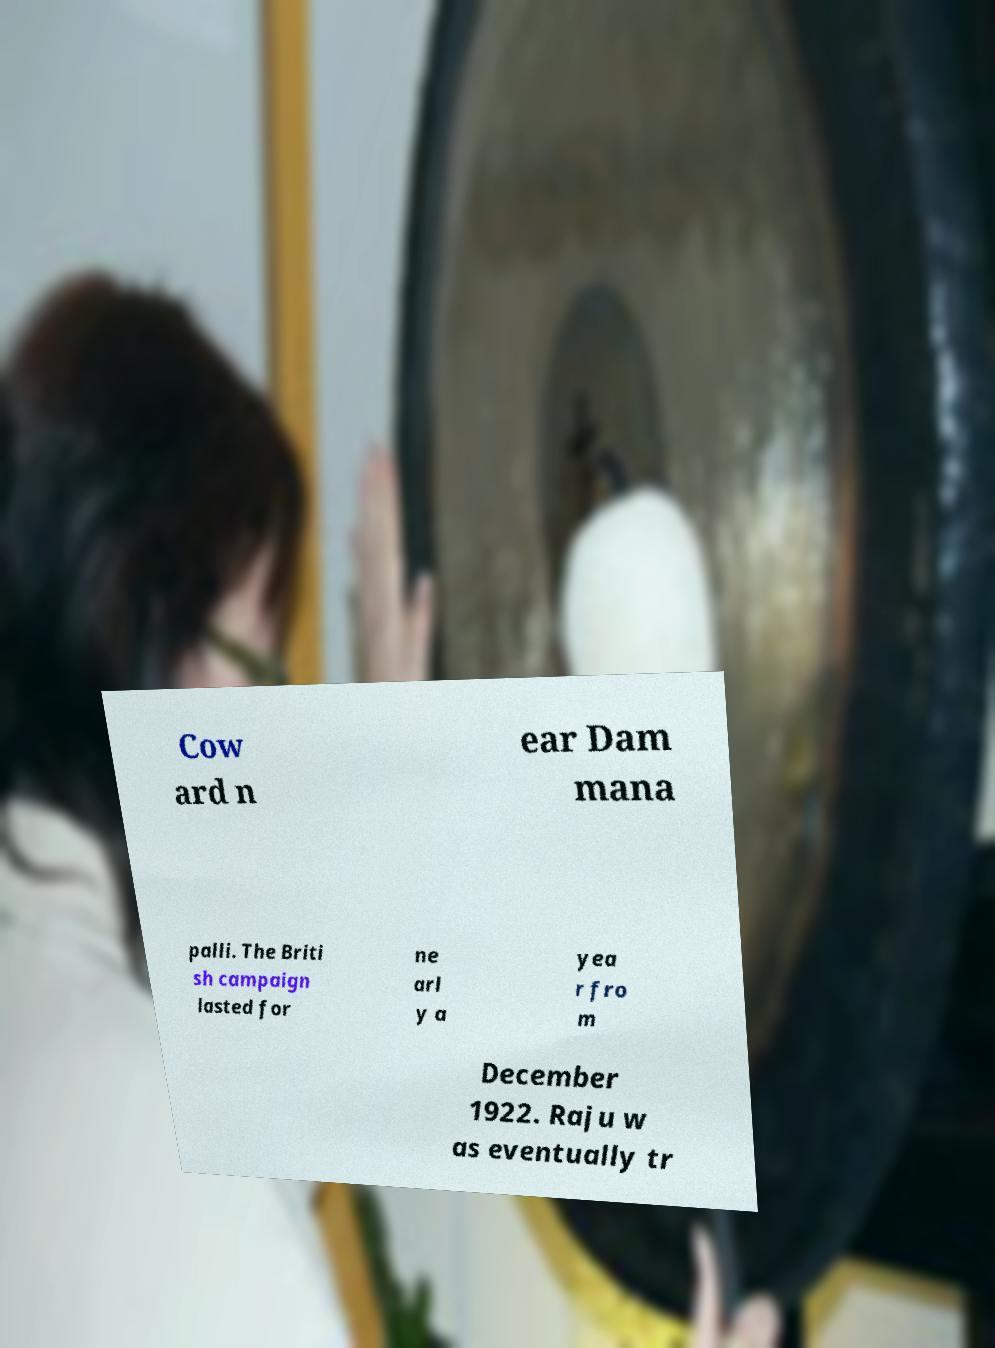I need the written content from this picture converted into text. Can you do that? Cow ard n ear Dam mana palli. The Briti sh campaign lasted for ne arl y a yea r fro m December 1922. Raju w as eventually tr 